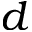Convert formula to latex. <formula><loc_0><loc_0><loc_500><loc_500>d</formula> 